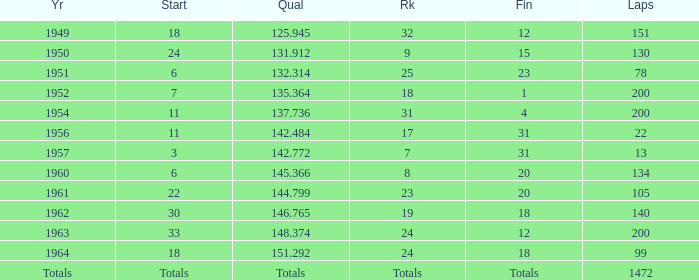Name the finish with Laps more than 200 Totals. Could you help me parse every detail presented in this table? {'header': ['Yr', 'Start', 'Qual', 'Rk', 'Fin', 'Laps'], 'rows': [['1949', '18', '125.945', '32', '12', '151'], ['1950', '24', '131.912', '9', '15', '130'], ['1951', '6', '132.314', '25', '23', '78'], ['1952', '7', '135.364', '18', '1', '200'], ['1954', '11', '137.736', '31', '4', '200'], ['1956', '11', '142.484', '17', '31', '22'], ['1957', '3', '142.772', '7', '31', '13'], ['1960', '6', '145.366', '8', '20', '134'], ['1961', '22', '144.799', '23', '20', '105'], ['1962', '30', '146.765', '19', '18', '140'], ['1963', '33', '148.374', '24', '12', '200'], ['1964', '18', '151.292', '24', '18', '99'], ['Totals', 'Totals', 'Totals', 'Totals', 'Totals', '1472']]} 